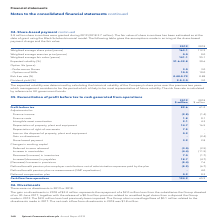According to Spirent Communications Plc's financial document, How is the fair value of share incentives estimated? at the date of grant using the Black-Scholes binomial model. The document states: "r value of share incentives has been estimated as at the date of grant using the Black-Scholes binomial model. The following table gives the assumptio..." Also, How was the expected volatility determined? by calculating the historical volatility of the Company’s share price over the previous two years which management considers to be the period which is likely to be most representative of future volatility.. The document states: "The expected volatility was determined by calculating the historical volatility of the Company’s share price over the previous two years which managem..." Also, What are the different option life (years) provided in the table with the assumptions in arriving at the share-based payment charge and the fair value? The document shows two values: Performance Shares and Options and SARs. From the document: "– Performance Shares 3.0 3.0 – Options and SARs 10.0 10.0..." Additionally, In which year was the Weighted average fair value (pence) larger? According to the financial document, 2019. The relevant text states: "2019 2018..." Also, can you calculate: What was the change in the Weighted average share price (pence)? Based on the calculation: 163.1-112.9, the result is 50.2. This is based on the information: "Weighted average share price (pence) 163.1 112.9 Weighted average share price (pence) 163.1 112.9..." The key data points involved are: 112.9, 163.1. Also, can you calculate: What was the percentage change in the Weighted average share price (pence)? To answer this question, I need to perform calculations using the financial data. The calculation is: (163.1-112.9)/112.9, which equals 44.46 (percentage). This is based on the information: "Weighted average share price (pence) 163.1 112.9 Weighted average share price (pence) 163.1 112.9..." The key data points involved are: 112.9, 163.1. 